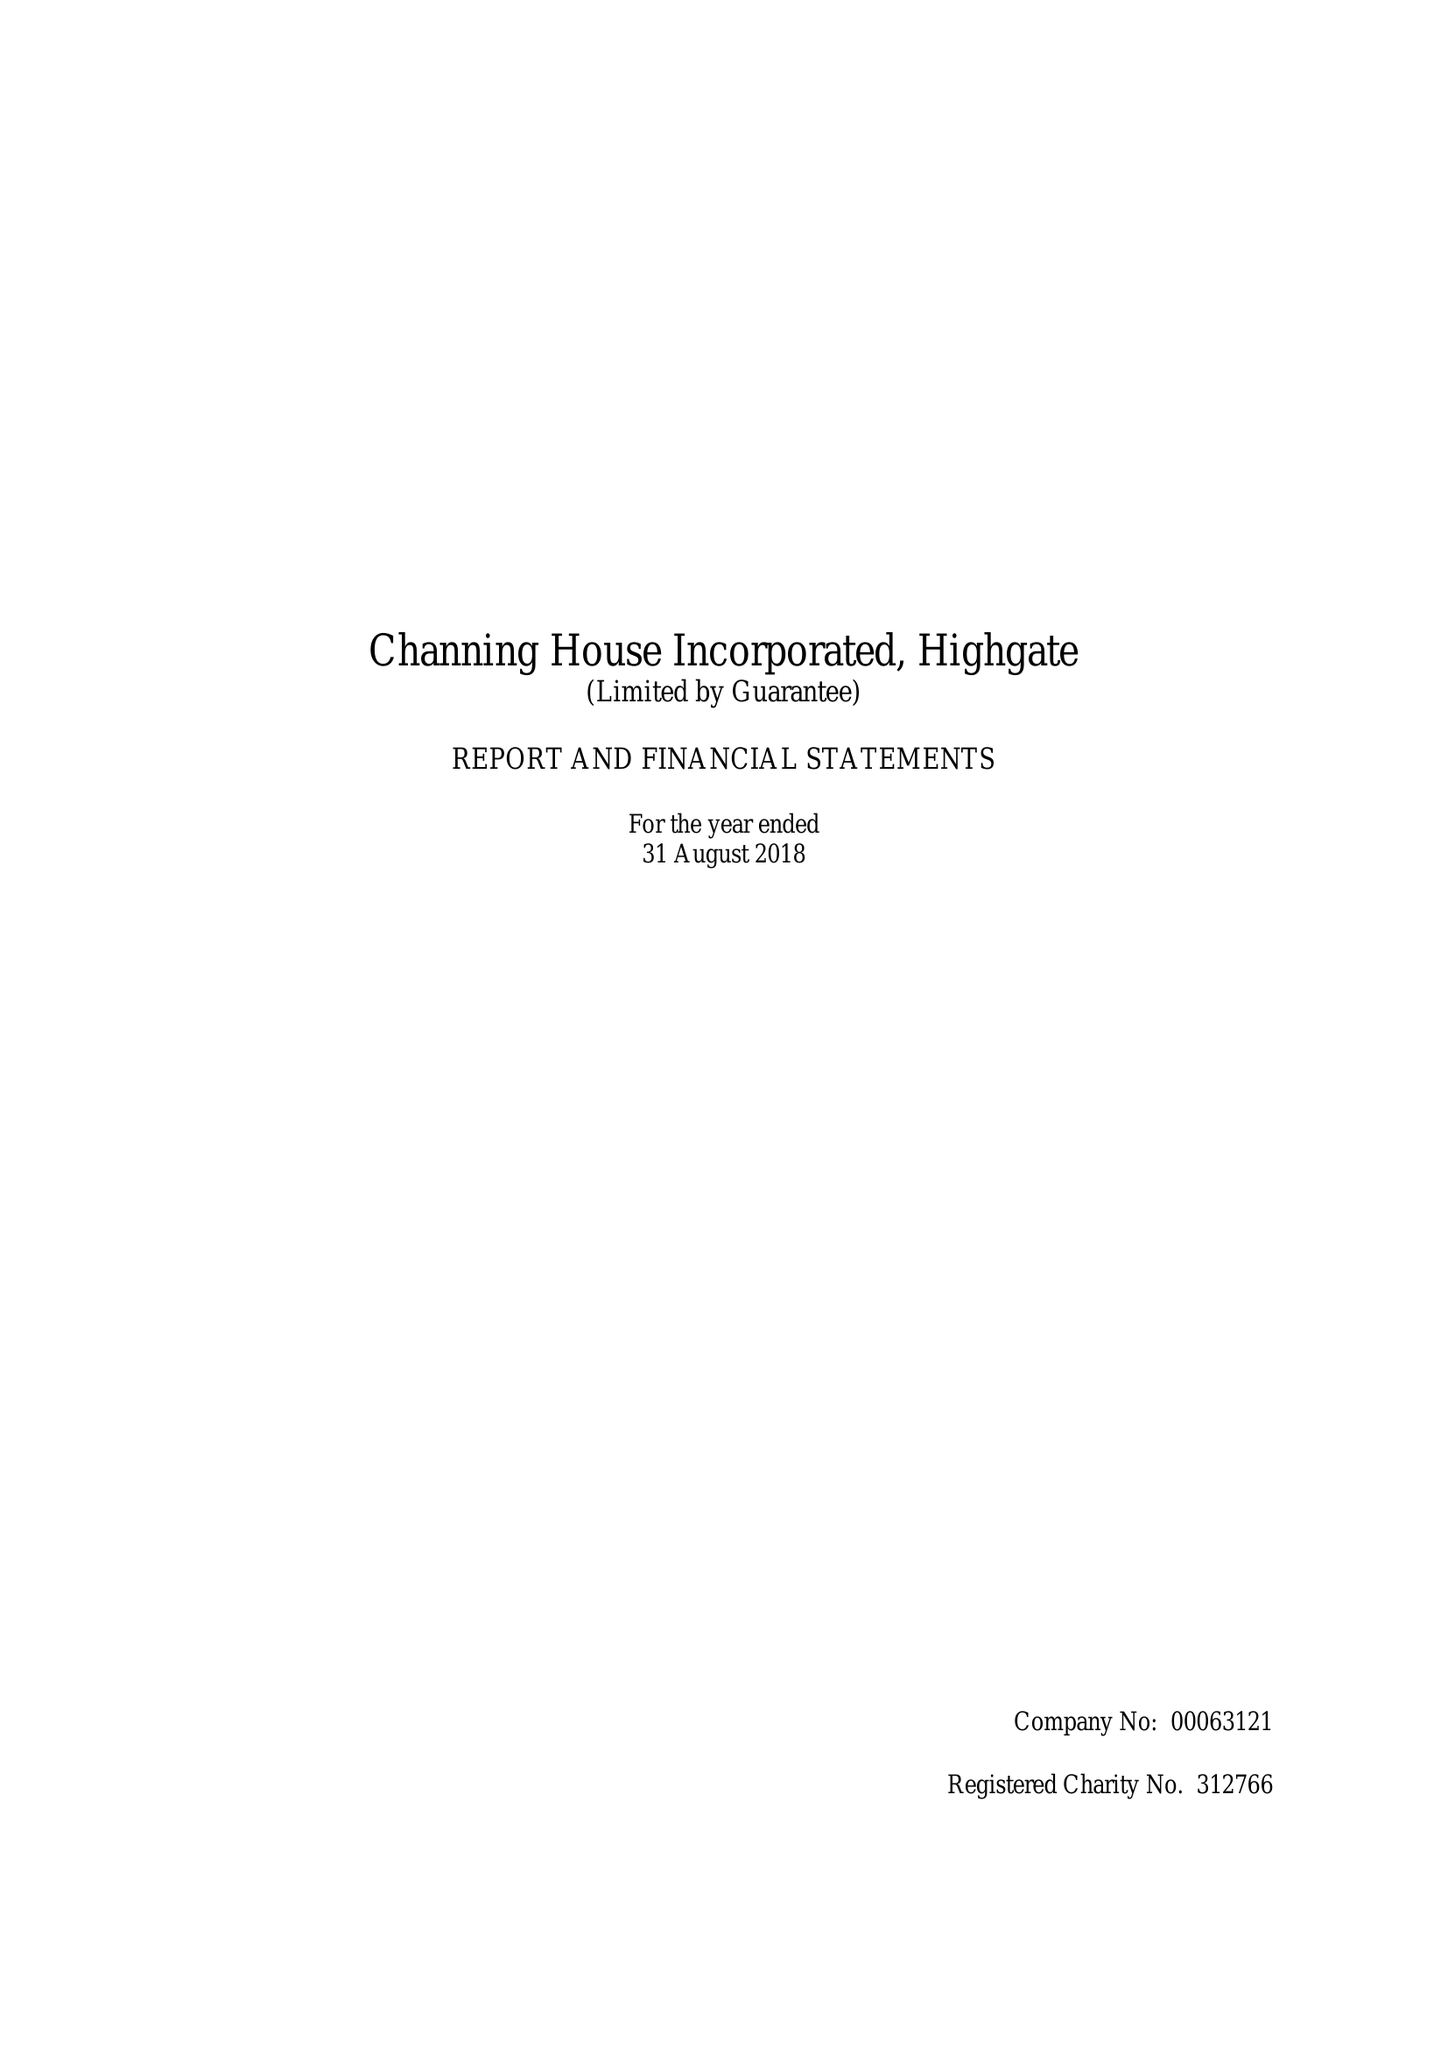What is the value for the charity_number?
Answer the question using a single word or phrase. 312766 